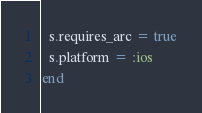<code> <loc_0><loc_0><loc_500><loc_500><_Ruby_>  s.requires_arc = true
  s.platform = :ios
end
</code> 